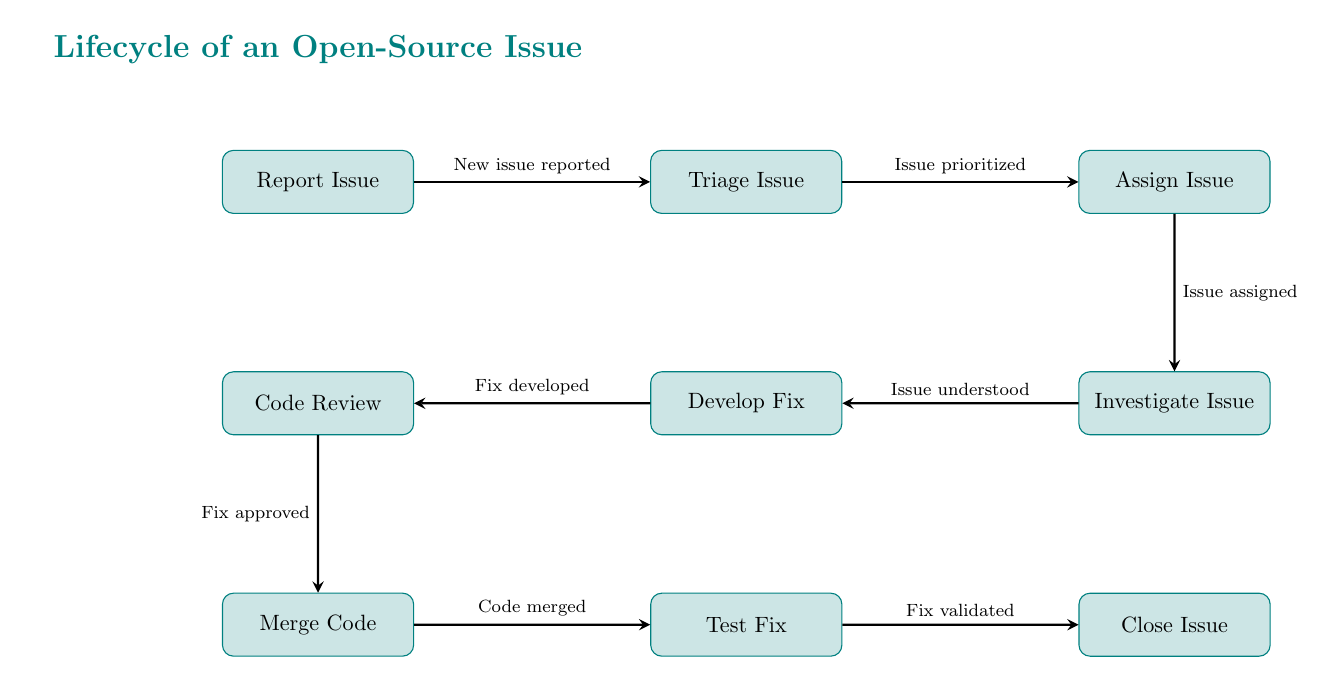What is the first stage of the open-source issue lifecycle? The first stage is indicated by the node on the far left of the diagram, which shows "Report Issue." This stage is where a new issue is logged in the system.
Answer: Report Issue How many total stages are there in this lifecycle? Counting the individual nodes in the diagram from "Report Issue" to "Close Issue," there are eight stages.
Answer: Eight What does the "Triage Issue" node represent in the flow? The "Triage Issue" node is the second stage in the lifecycle where the reported issue is evaluated for priority and urgency, leading to the assignment stage.
Answer: Issue prioritized What comes after the "Assign Issue" stage? After the "Assign Issue" stage, the flow proceeds to the "Investigate Issue" stage. This connection is represented by an arrow pointing from "Assign Issue" to "Investigate Issue."
Answer: Investigate Issue What is the final step before closing the issue? The final step before closing the issue is represented by the "Test Fix" node. Once the fix has been tested successfully, the final action is to close the issue.
Answer: Test Fix How do you go from "Develop Fix" to "Merge Code"? To go from "Develop Fix" to "Merge Code," the flow indicates a connection that shows "Fix approved" as the required condition for moving forward, meaning the code must pass the review before merging.
Answer: Fix approved Which node directly follows "Investigate Issue"? The node that directly follows "Investigate Issue" is "Develop Fix," indicating that after understanding the issue, the development of a fix begins next.
Answer: Develop Fix What does the arrow from "Merge Code" to "Test Fix" represent? The arrow from "Merge Code" to "Test Fix" represents the action of moving onward in the workflow once the code has been merged, which indicates that the next step is to test the merged code for validation.
Answer: Code merged In what order are the steps taken to resolve an issue? The order is sequentially shown from "Report Issue" to "Triage Issue," followed by "Assign Issue," "Investigate Issue," "Develop Fix," "Code Review," "Merge Code," "Test Fix," and finally "Close Issue." This sequence outlines the complete workflow for resolution.
Answer: Report Issue, Triage Issue, Assign Issue, Investigate Issue, Develop Fix, Code Review, Merge Code, Test Fix, Close Issue 